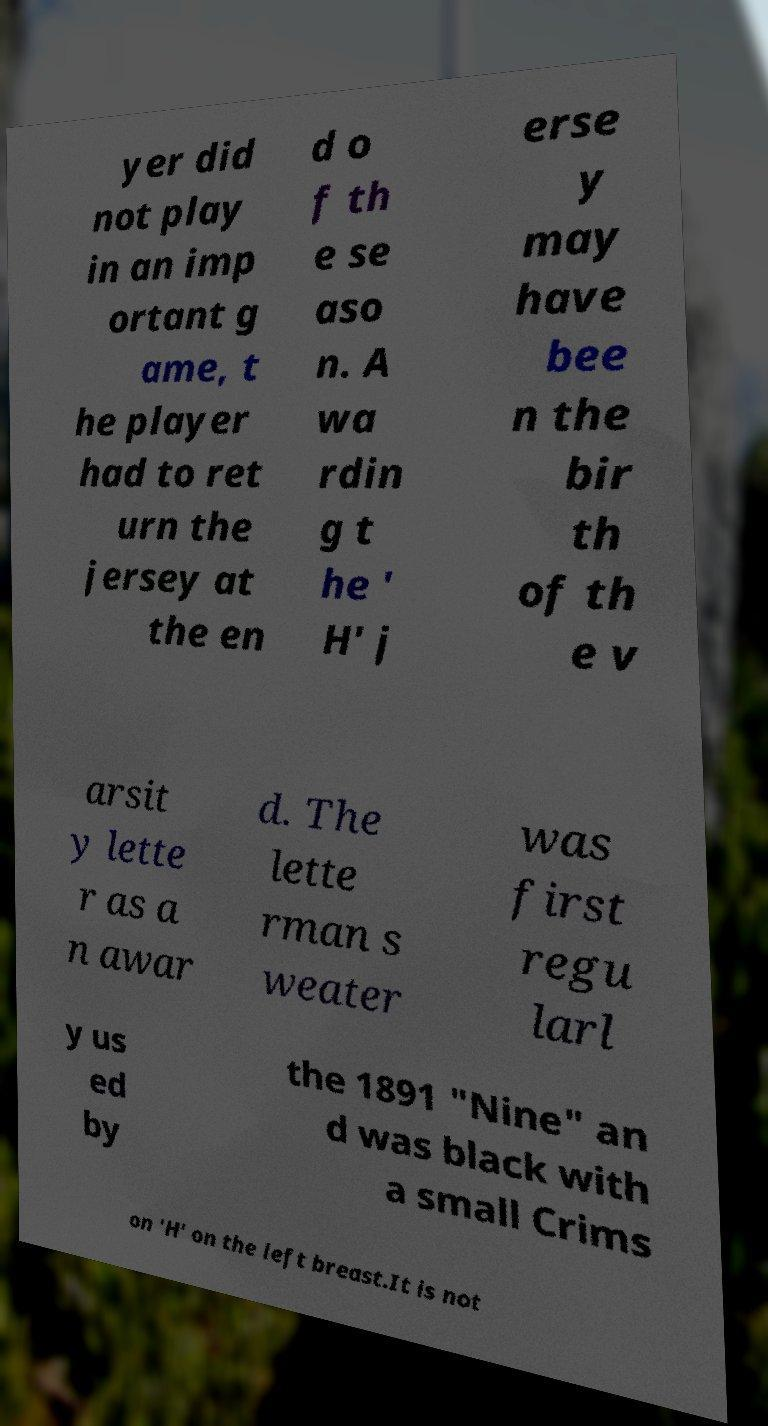Can you read and provide the text displayed in the image?This photo seems to have some interesting text. Can you extract and type it out for me? yer did not play in an imp ortant g ame, t he player had to ret urn the jersey at the en d o f th e se aso n. A wa rdin g t he ' H' j erse y may have bee n the bir th of th e v arsit y lette r as a n awar d. The lette rman s weater was first regu larl y us ed by the 1891 "Nine" an d was black with a small Crims on 'H' on the left breast.It is not 